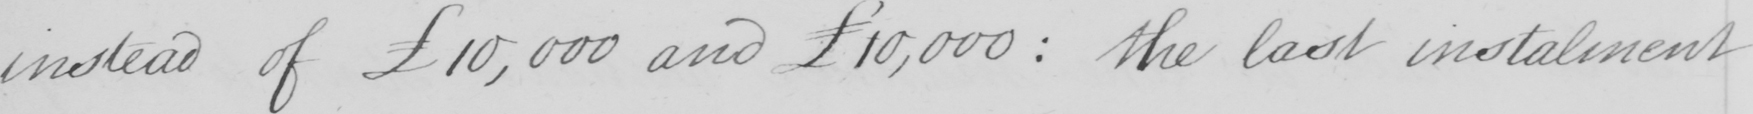Can you read and transcribe this handwriting? instead of £10,000 and £10,000 :  the last instalment 